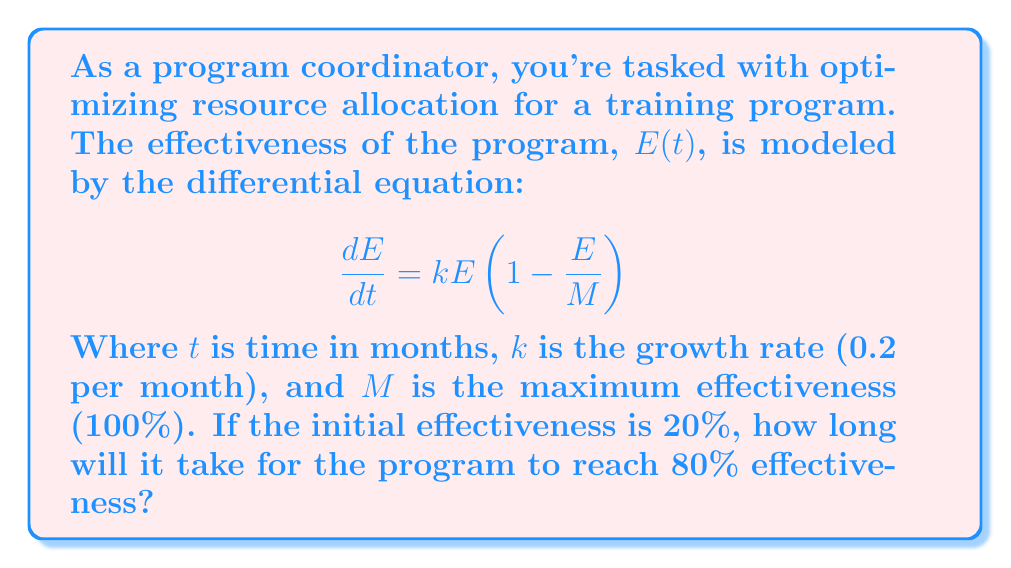Show me your answer to this math problem. Let's solve this problem step-by-step:

1) First, we recognize this as a separable differential equation. We can separate the variables:

   $$\frac{dE}{E(1-\frac{E}{M})} = k dt$$

2) Integrate both sides:

   $$\int \frac{dE}{E(1-\frac{E}{M})} = \int k dt$$

3) The left side can be integrated using partial fractions:

   $$\ln|E| - \ln|M-E| = kt + C$$

4) Simplify:

   $$\ln|\frac{E}{M-E}| = kt + C$$

5) Apply the initial condition: At t=0, E=20% (0.2M):

   $$\ln|\frac{0.2M}{M-0.2M}| = k(0) + C$$
   $$\ln|0.25| = C$$
   $$C = -1.3863$$

6) Now, we want to find t when E=80% (0.8M):

   $$\ln|\frac{0.8M}{M-0.8M}| = kt - 1.3863$$
   $$\ln|4| = kt - 1.3863$$
   $$1.3863 = kt - 1.3863$$
   $$2.7726 = kt$$

7) Solve for t:

   $$t = \frac{2.7726}{k} = \frac{2.7726}{0.2} = 13.863$$
Answer: 13.86 months 